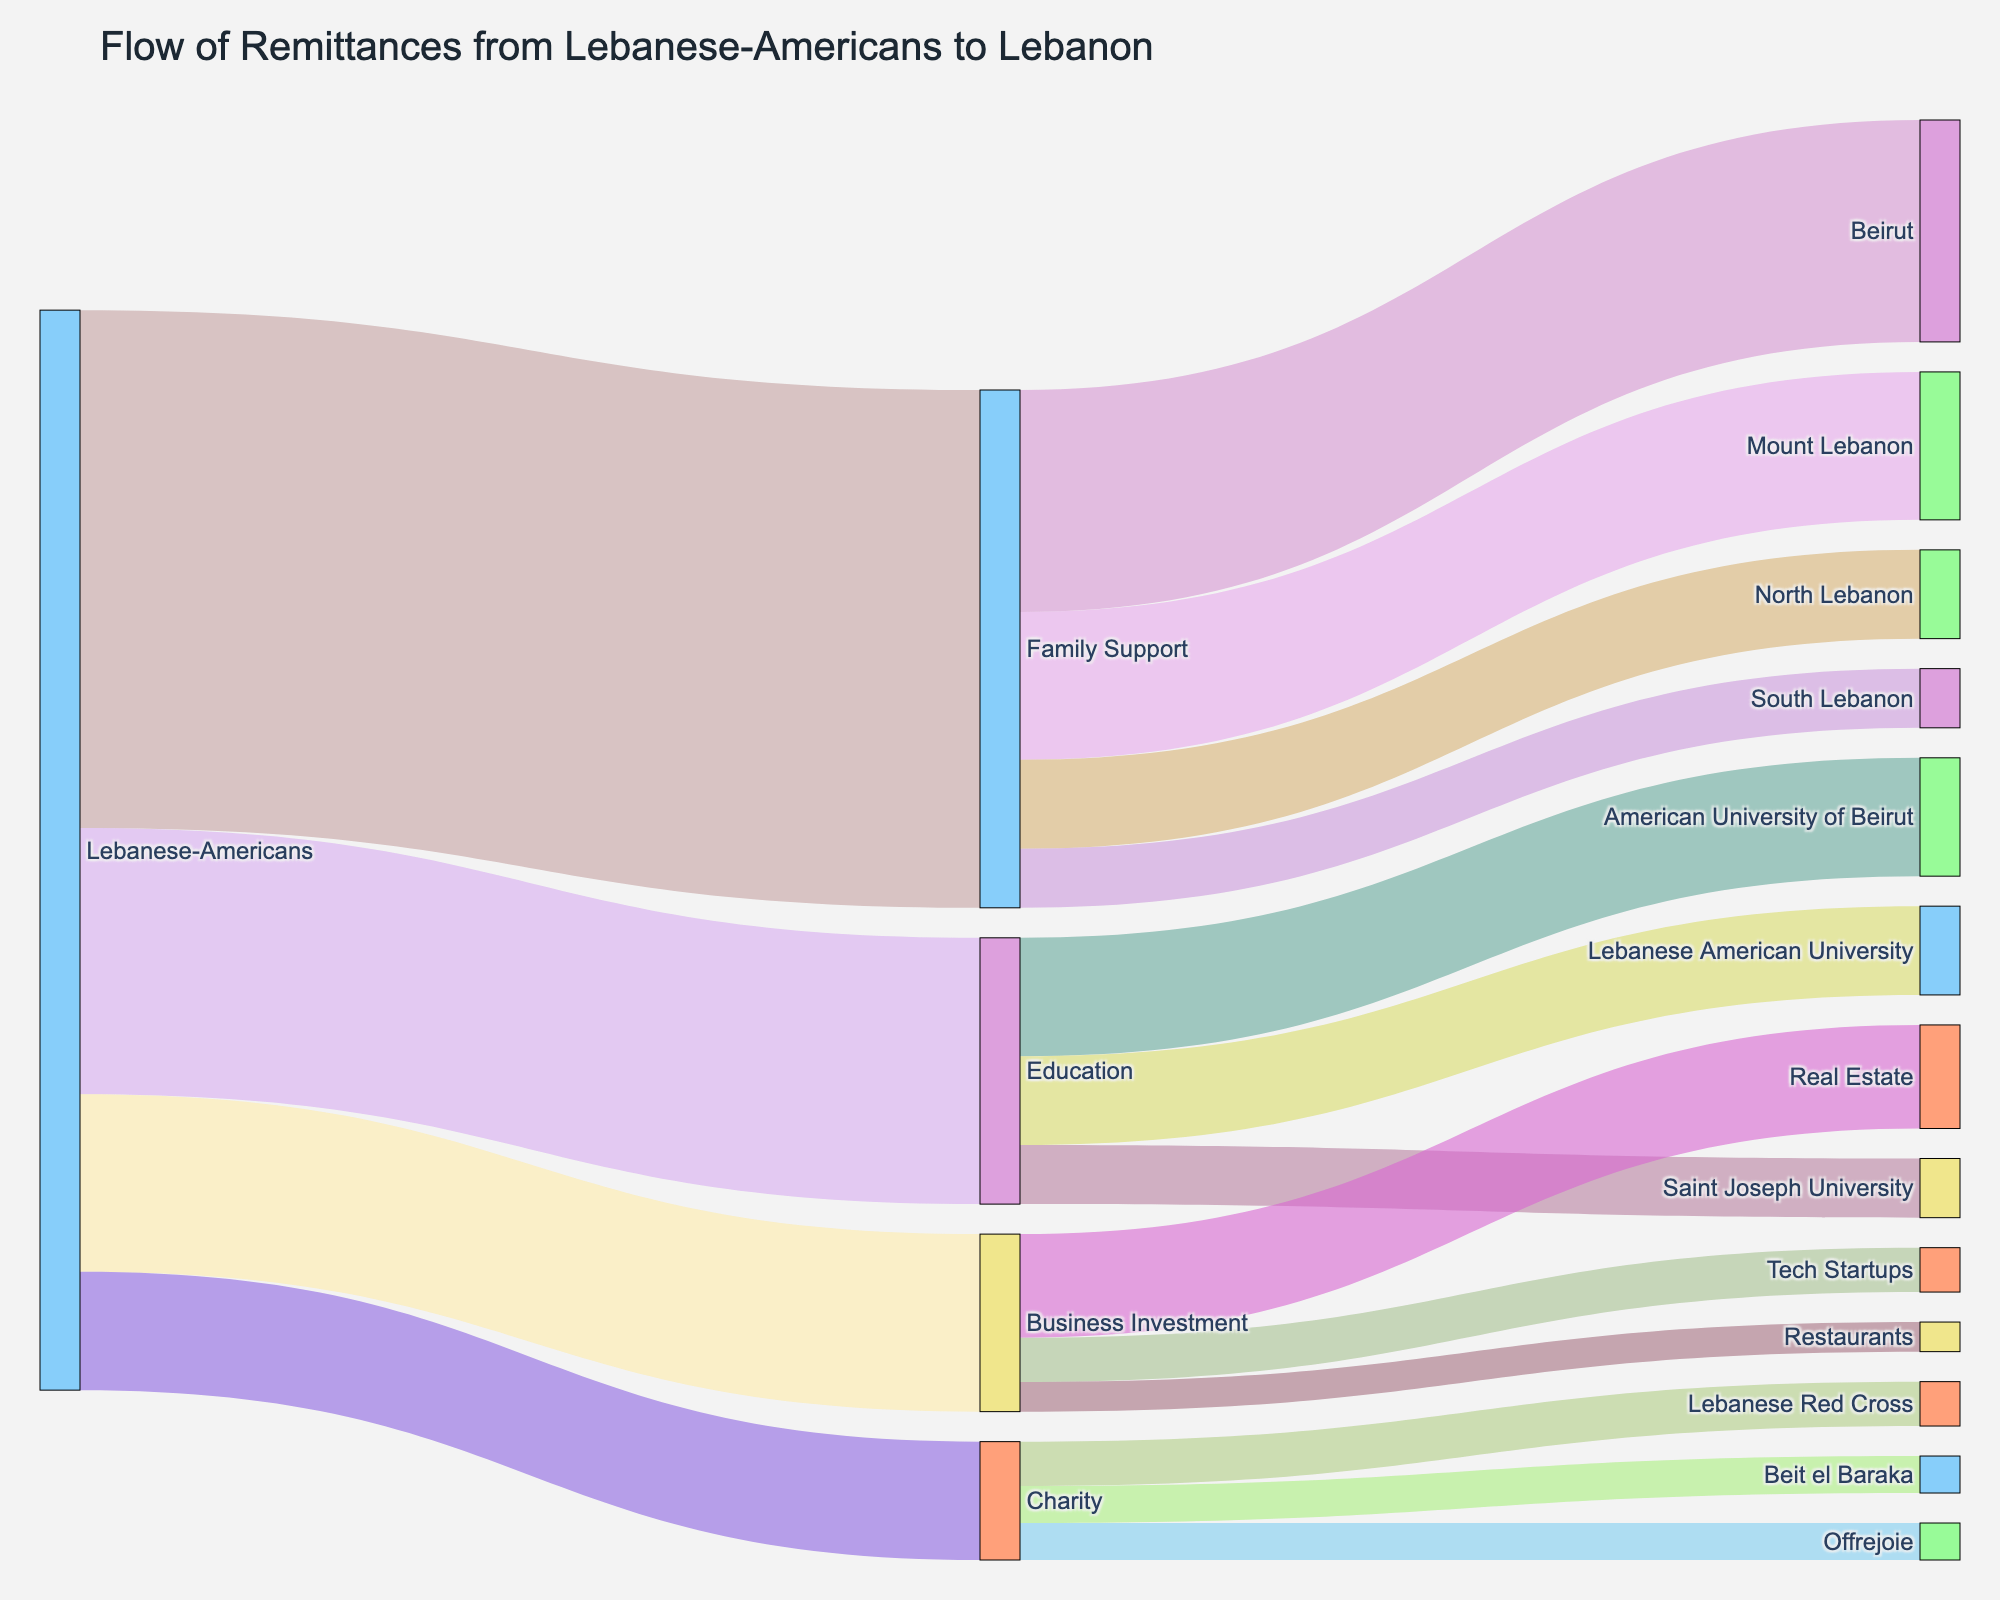What is the total value of remittances sent from Lebanese-Americans? To find the total value, sum up the remittances for all listed purposes (Family Support, Education, Business Investment, Charity). ($350+$180+$120+$80=$730)
Answer: $730 Which purpose received the highest remittances from Lebanese-Americans? Comparing the remittance values for each purpose, Family Support has the highest value ($350).
Answer: Family Support What is the combined total of remittances sent specifically for Education and Business Investment? Summing the values for Education and Business Investment. ($180+$120=$300)
Answer: $300 Which recipient region received the least remittance from Family Support? Among Beirut, Mount Lebanon, North Lebanon, and South Lebanon, South Lebanon received the least ($40).
Answer: South Lebanon What is the total remittance value allocated to Business Investment-related targets? Summing the remittance values to Real Estate, Tech Startups, and Restaurants. ($70+$30+$20=$120)
Answer: $120 How much more money was sent for Family Support compared to Charity? Subtracting the value for Charity from the value for Family Support. ($350-$80=$270)
Answer: $270 Between the American University of Beirut and Lebanese American University, which received more remittance for Education? Comparing the values for American University of Beirut and Lebanese American University, AUB received more ($80 vs $60).
Answer: American University of Beirut What is the total amount of remittances received by Beit el Baraka? Beit el Baraka received $25 from Charity.
Answer: $25 Which university received the least amount of remittances for Education? Among American University of Beirut, Lebanese American University, and Saint Joseph University, the latter received the least ($40).
Answer: Saint Joseph University How does the remittance for Tech Startups compare to that for Restaurants in terms of value? Tech Startups received $30, which is $10 more than Restaurants that received $20.
Answer: Tech Startups What is the total amount of charity remittances distributed among Lebanese charities? Summing the values for Lebanese Red Cross, Beit el Baraka, and Offrejoie. ($30+$25+$25=$80)
Answer: $80 